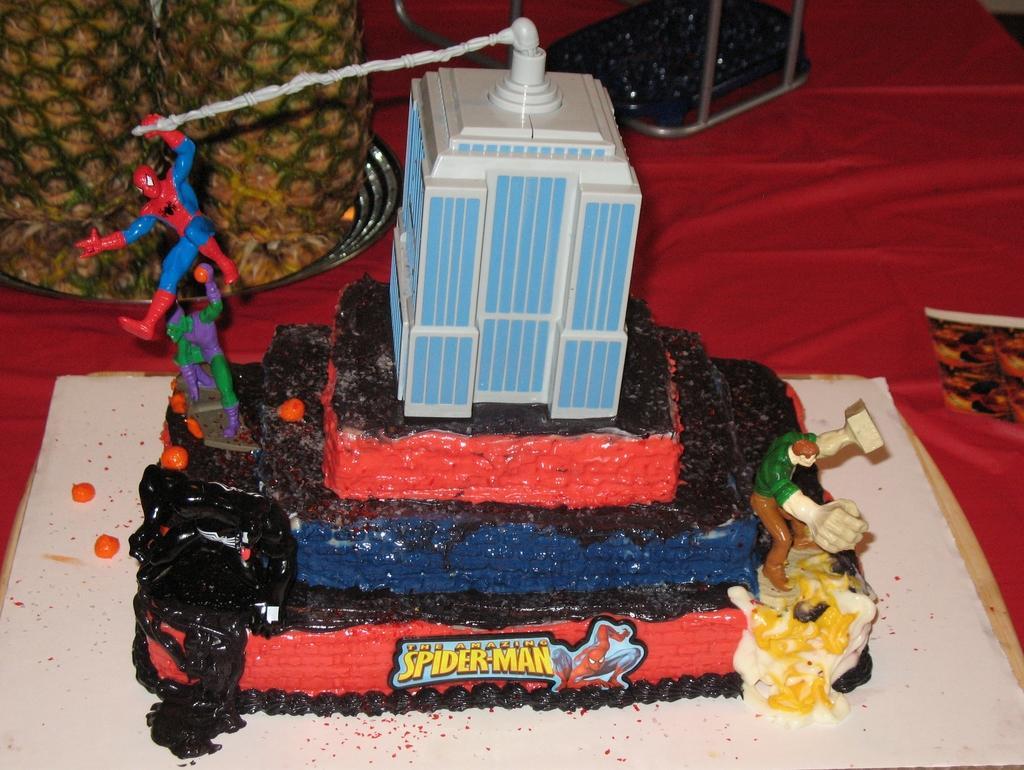Can you describe this image briefly? Here we can see toys,cake,fruits and objects on the red surface. 